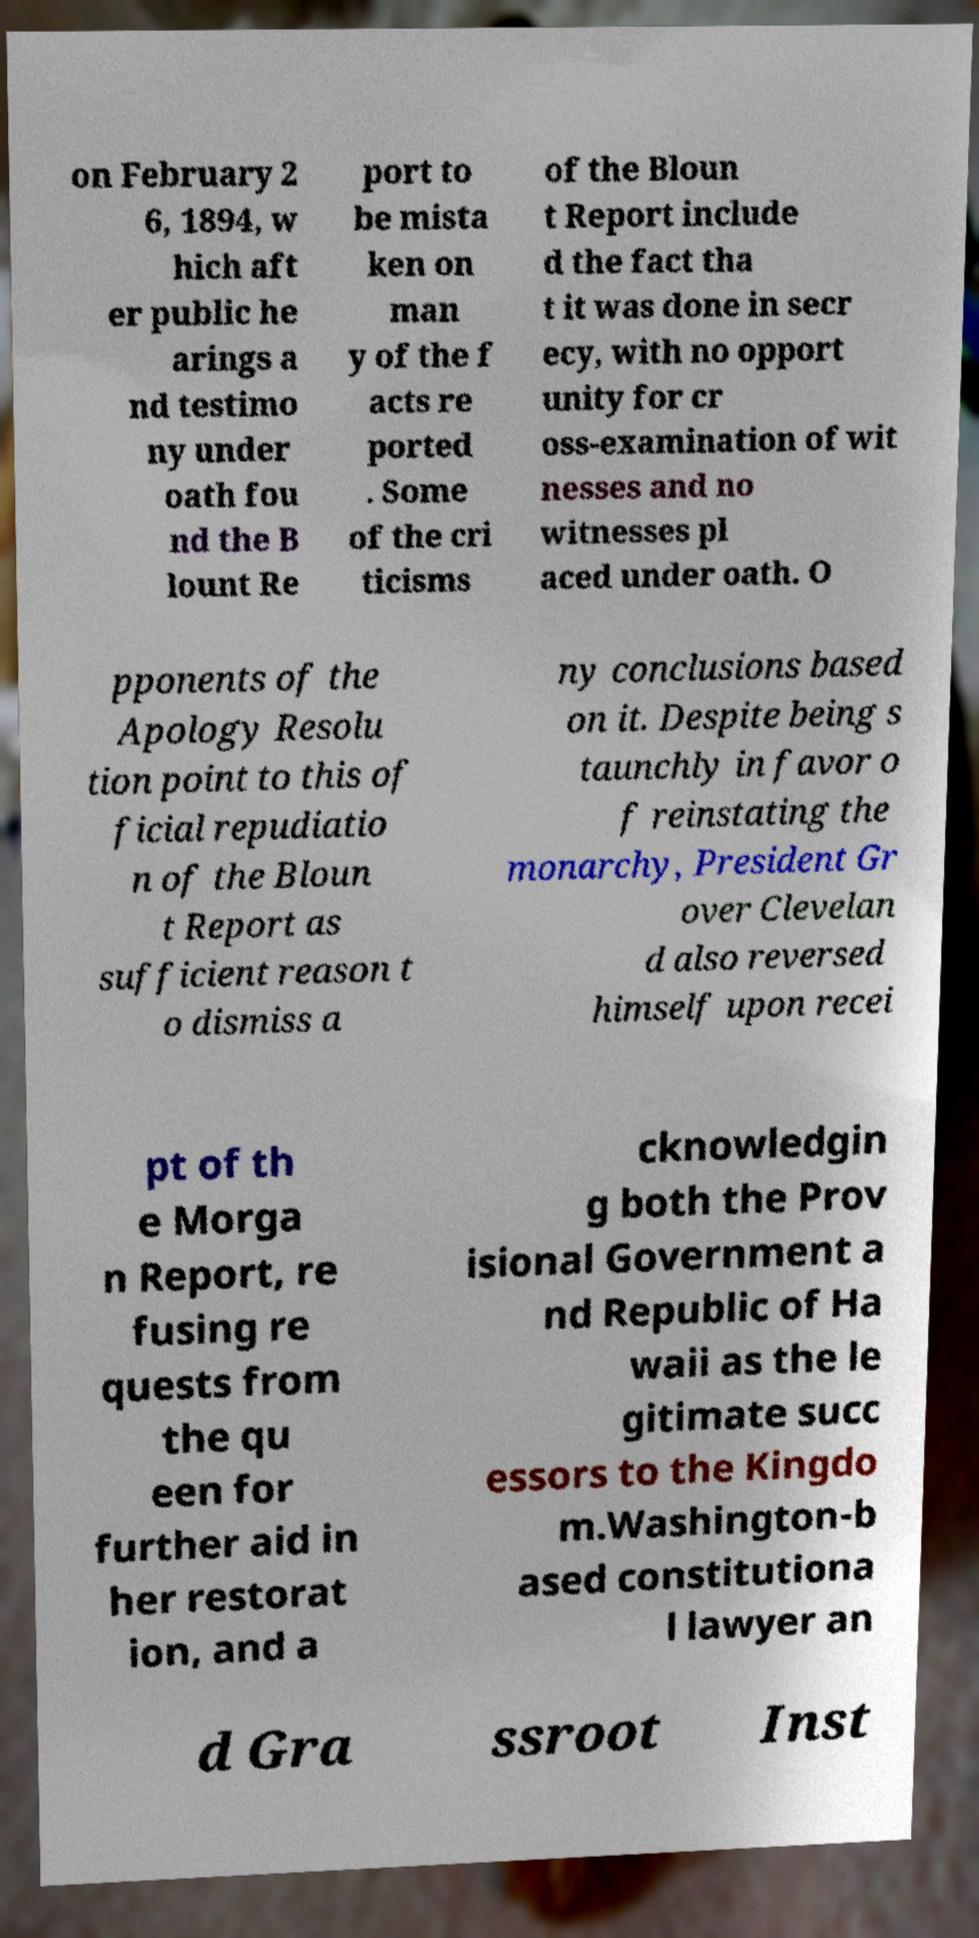What messages or text are displayed in this image? I need them in a readable, typed format. on February 2 6, 1894, w hich aft er public he arings a nd testimo ny under oath fou nd the B lount Re port to be mista ken on man y of the f acts re ported . Some of the cri ticisms of the Bloun t Report include d the fact tha t it was done in secr ecy, with no opport unity for cr oss-examination of wit nesses and no witnesses pl aced under oath. O pponents of the Apology Resolu tion point to this of ficial repudiatio n of the Bloun t Report as sufficient reason t o dismiss a ny conclusions based on it. Despite being s taunchly in favor o f reinstating the monarchy, President Gr over Clevelan d also reversed himself upon recei pt of th e Morga n Report, re fusing re quests from the qu een for further aid in her restorat ion, and a cknowledgin g both the Prov isional Government a nd Republic of Ha waii as the le gitimate succ essors to the Kingdo m.Washington-b ased constitutiona l lawyer an d Gra ssroot Inst 